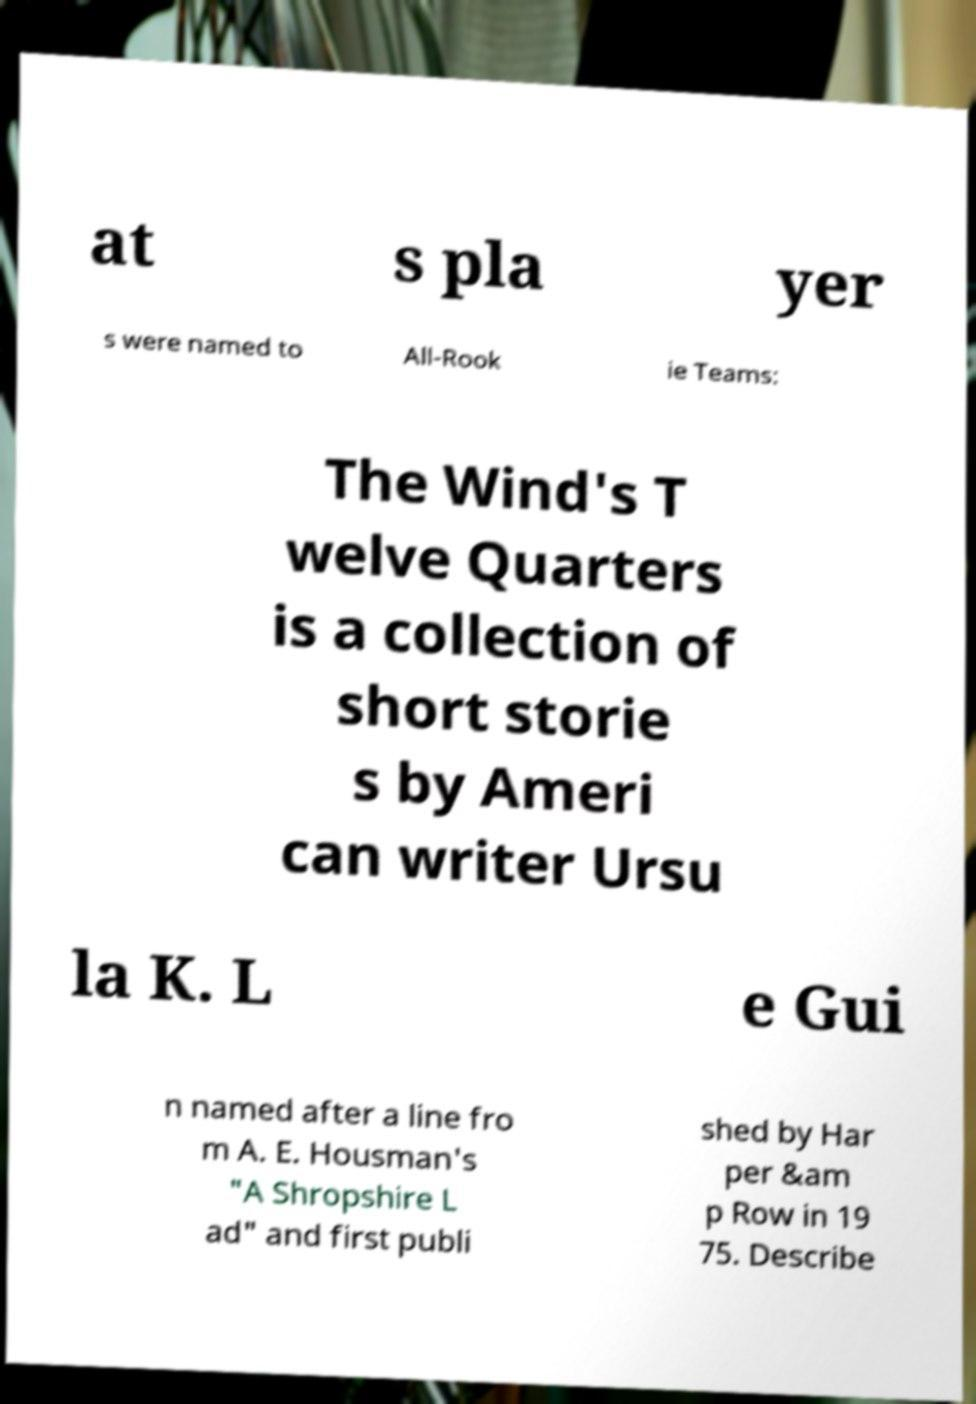Please read and relay the text visible in this image. What does it say? at s pla yer s were named to All-Rook ie Teams: The Wind's T welve Quarters is a collection of short storie s by Ameri can writer Ursu la K. L e Gui n named after a line fro m A. E. Housman's "A Shropshire L ad" and first publi shed by Har per &am p Row in 19 75. Describe 